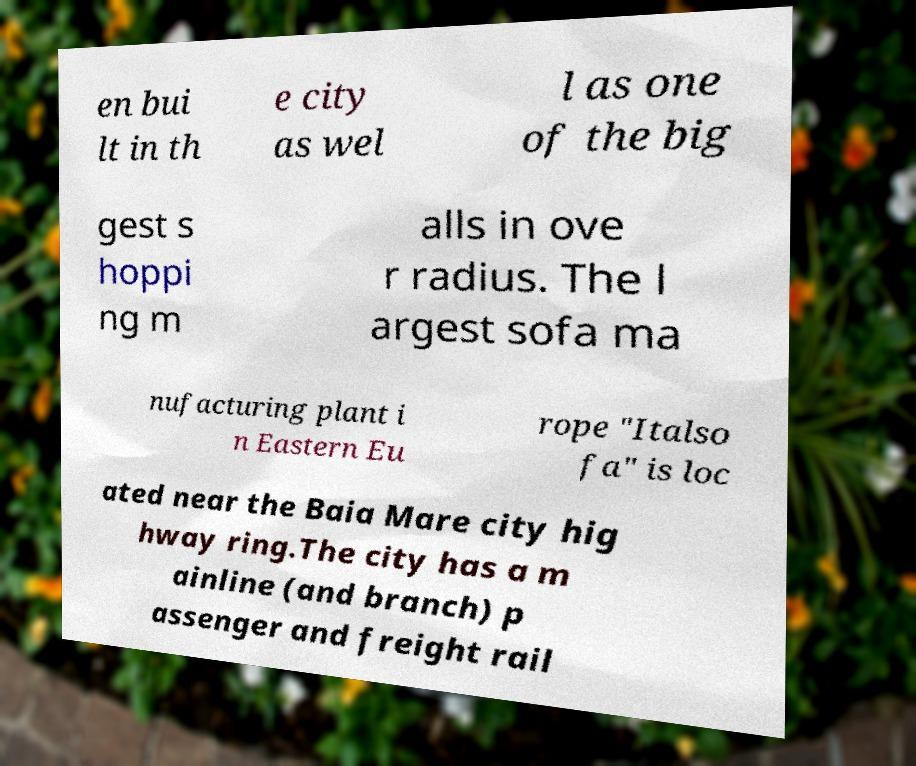Could you assist in decoding the text presented in this image and type it out clearly? en bui lt in th e city as wel l as one of the big gest s hoppi ng m alls in ove r radius. The l argest sofa ma nufacturing plant i n Eastern Eu rope "Italso fa" is loc ated near the Baia Mare city hig hway ring.The city has a m ainline (and branch) p assenger and freight rail 